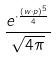Convert formula to latex. <formula><loc_0><loc_0><loc_500><loc_500>\frac { e ^ { \cdot \frac { ( w \cdot p ) ^ { 5 } } { 4 } } } { \sqrt { 4 \pi } }</formula> 